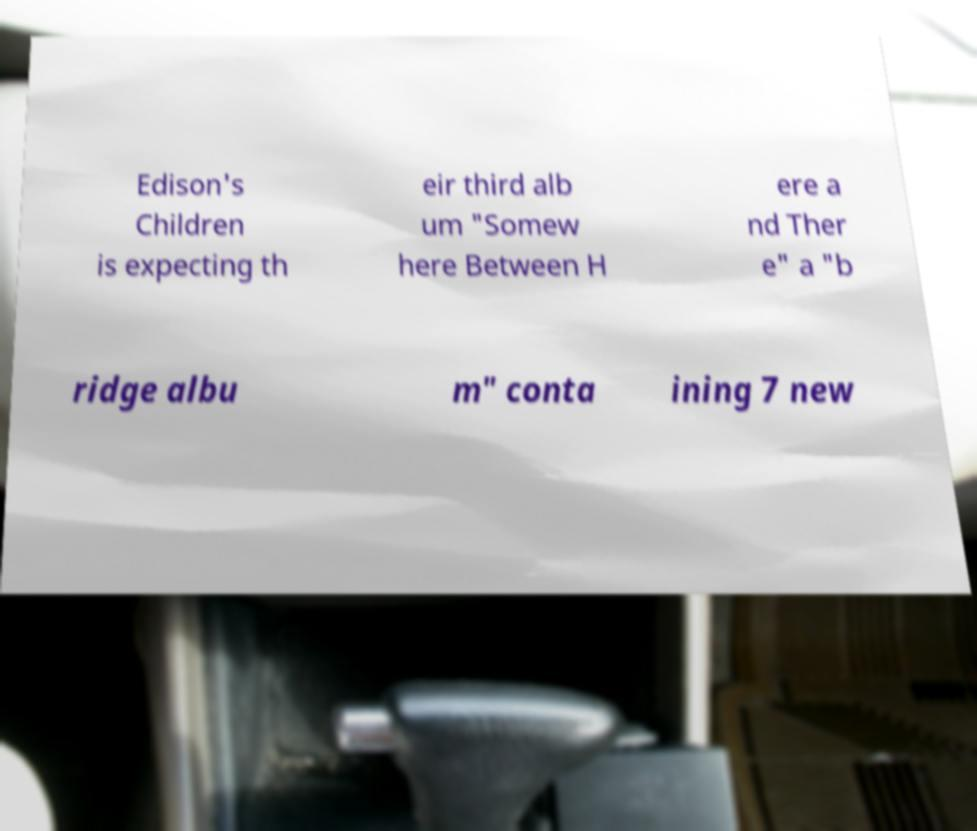Please identify and transcribe the text found in this image. Edison's Children is expecting th eir third alb um "Somew here Between H ere a nd Ther e" a "b ridge albu m" conta ining 7 new 